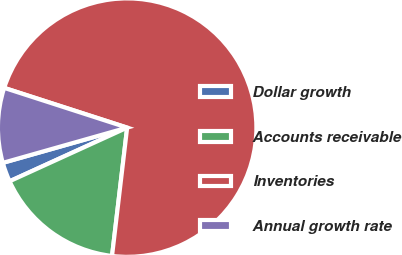Convert chart to OTSL. <chart><loc_0><loc_0><loc_500><loc_500><pie_chart><fcel>Dollar growth<fcel>Accounts receivable<fcel>Inventories<fcel>Annual growth rate<nl><fcel>2.42%<fcel>16.32%<fcel>71.9%<fcel>9.37%<nl></chart> 